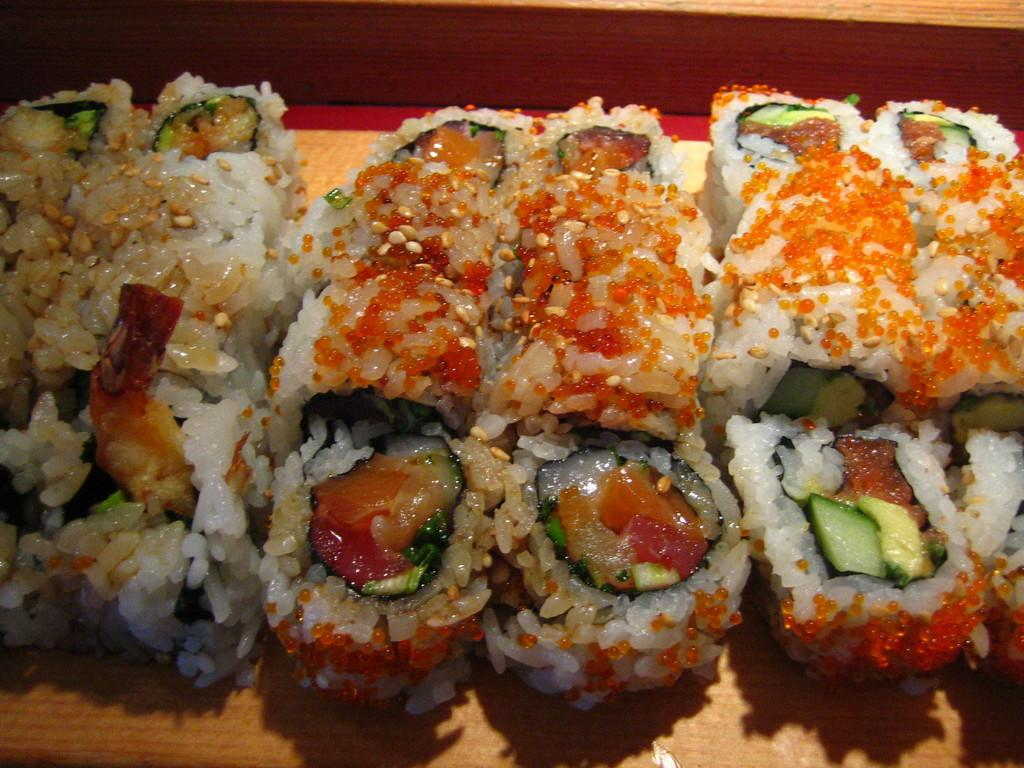What types of food items can be seen in the image? There are food items in the image, but their specific types are not mentioned. What colors are the food items in the image? The food items have various colors: white, green, cream, red, and orange. What is the color of the surface the food items are on? The surface the food items are on is cream-colored. How many lead pipes are visible in the image? There is no mention of lead pipes in the image, so it is not possible to determine their presence or quantity. 